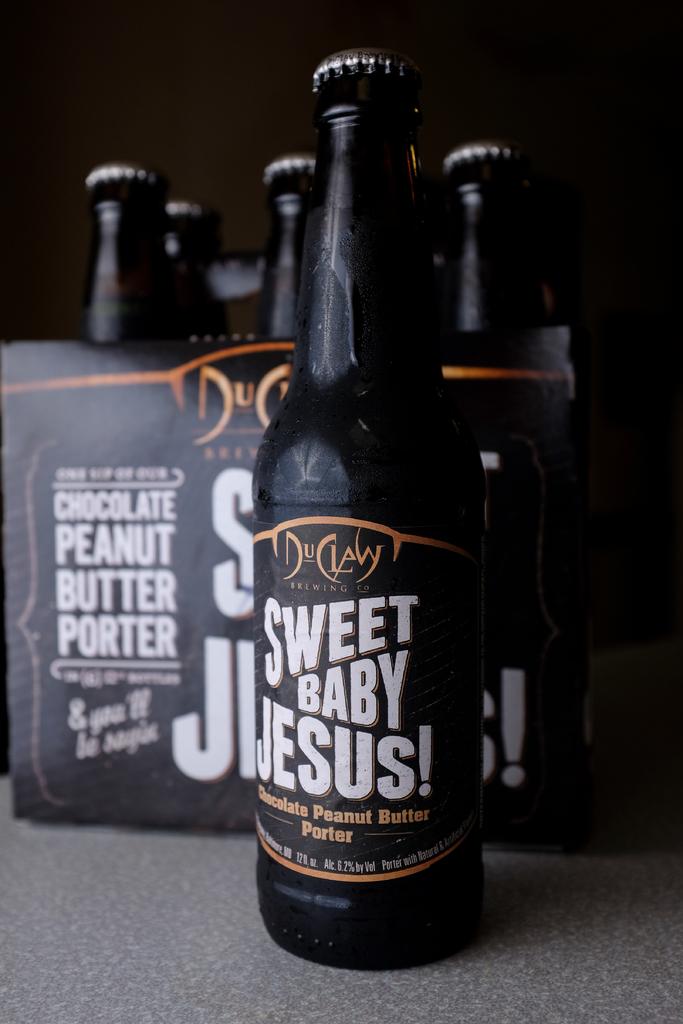What is the volume of each bottle?
Keep it short and to the point. 12 fl oz. 